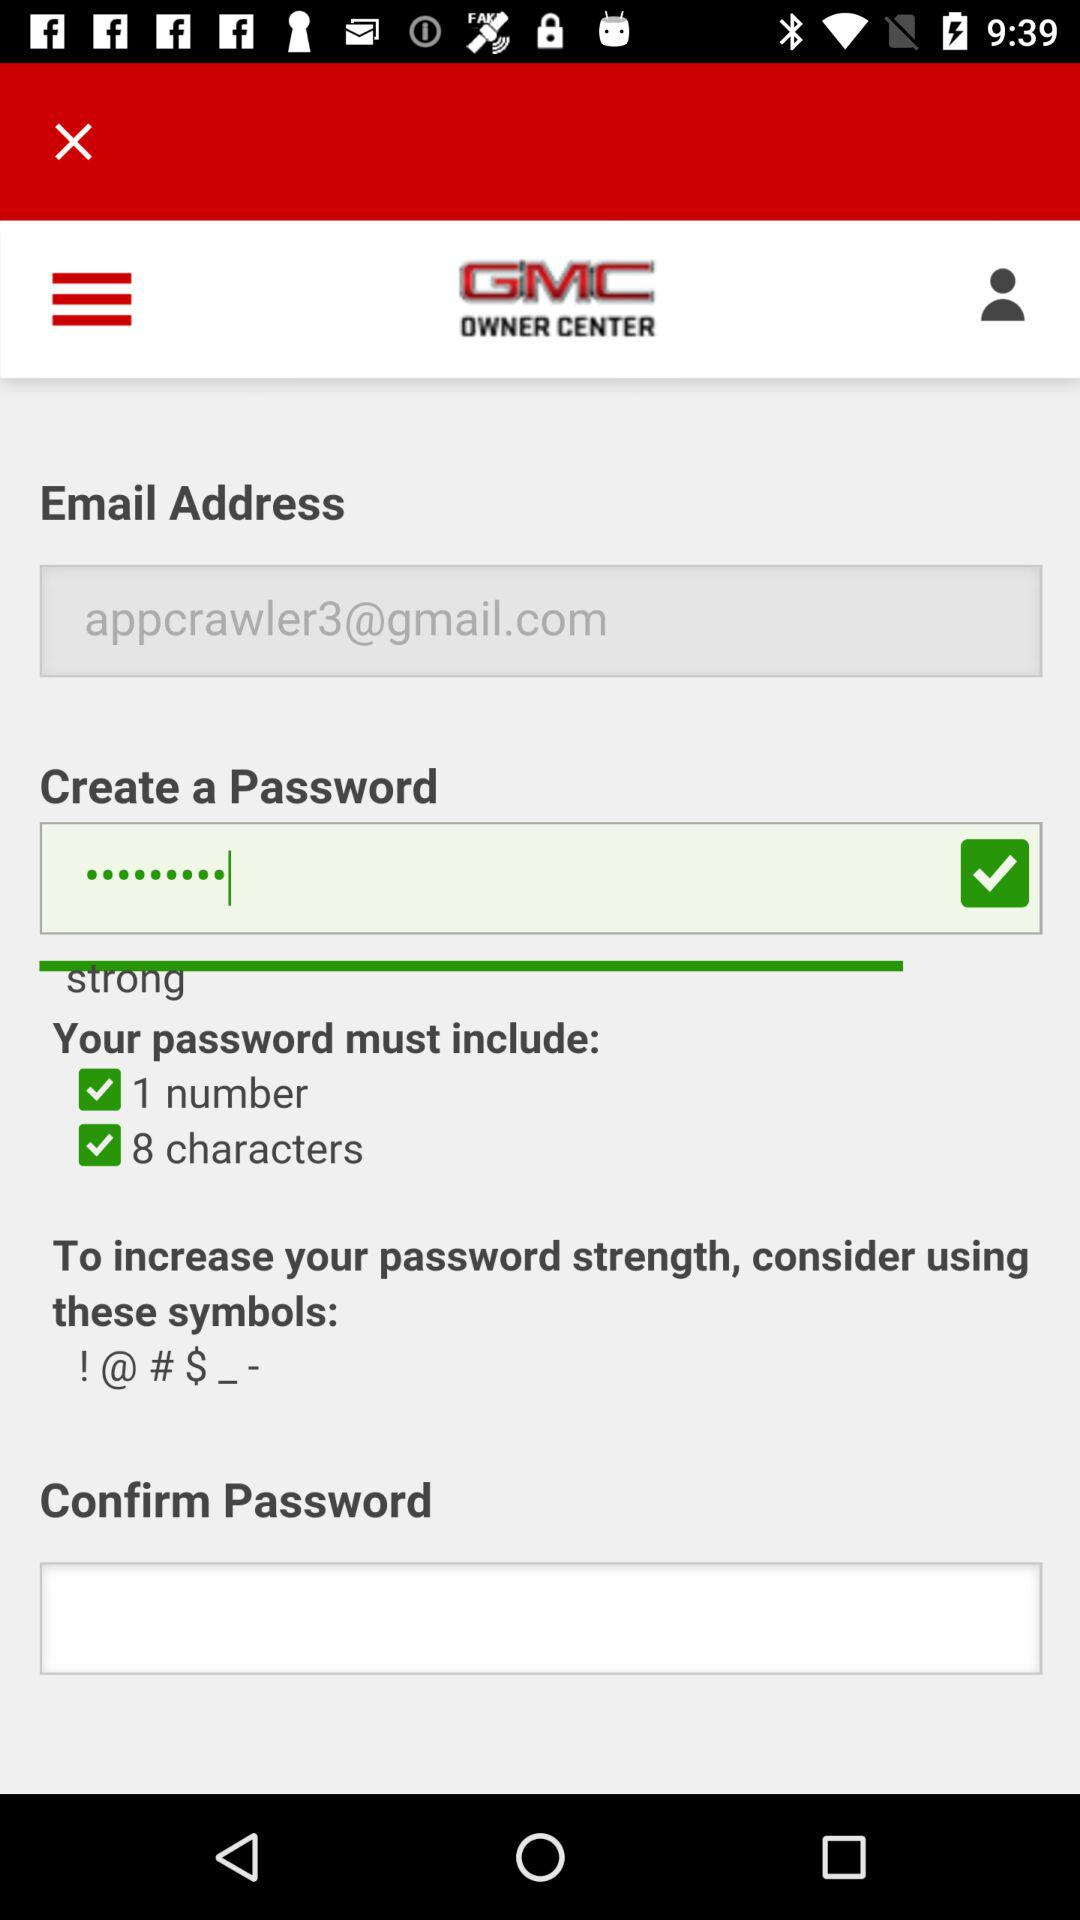What is the application name? The application name is "GMC". 